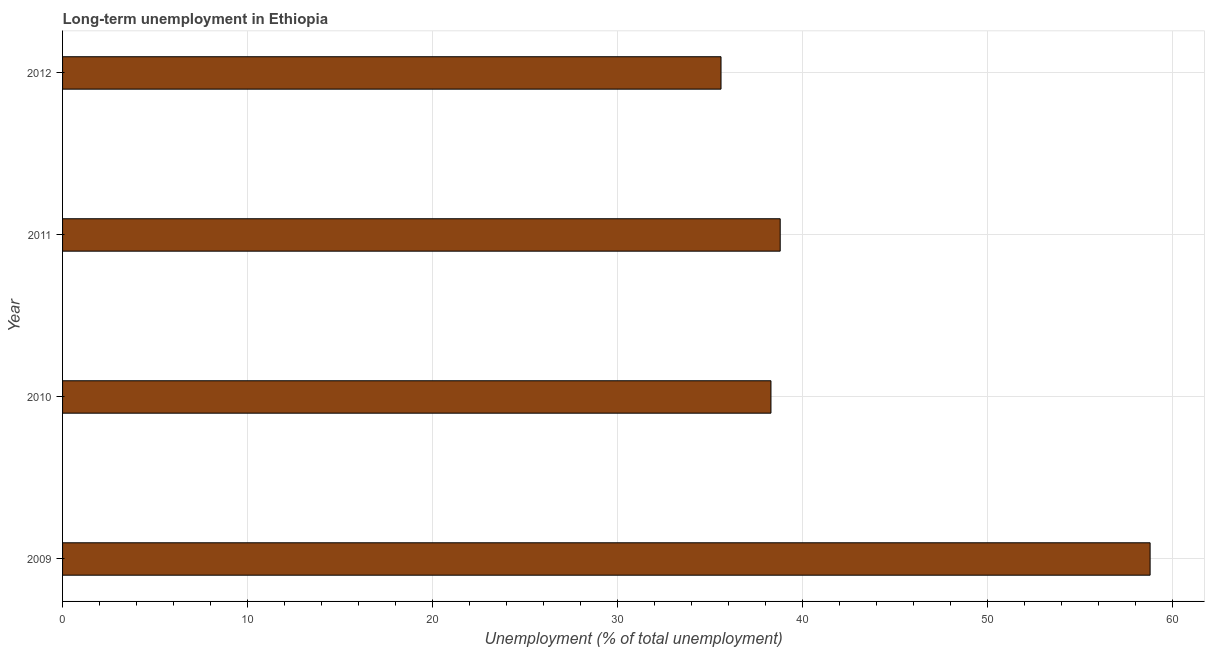Does the graph contain grids?
Your answer should be very brief. Yes. What is the title of the graph?
Provide a succinct answer. Long-term unemployment in Ethiopia. What is the label or title of the X-axis?
Keep it short and to the point. Unemployment (% of total unemployment). What is the label or title of the Y-axis?
Keep it short and to the point. Year. What is the long-term unemployment in 2010?
Offer a terse response. 38.3. Across all years, what is the maximum long-term unemployment?
Make the answer very short. 58.8. Across all years, what is the minimum long-term unemployment?
Give a very brief answer. 35.6. In which year was the long-term unemployment maximum?
Your response must be concise. 2009. In which year was the long-term unemployment minimum?
Provide a short and direct response. 2012. What is the sum of the long-term unemployment?
Make the answer very short. 171.5. What is the difference between the long-term unemployment in 2011 and 2012?
Ensure brevity in your answer.  3.2. What is the average long-term unemployment per year?
Provide a short and direct response. 42.88. What is the median long-term unemployment?
Your response must be concise. 38.55. What is the ratio of the long-term unemployment in 2009 to that in 2011?
Offer a terse response. 1.51. What is the difference between the highest and the lowest long-term unemployment?
Your answer should be compact. 23.2. How many years are there in the graph?
Give a very brief answer. 4. Are the values on the major ticks of X-axis written in scientific E-notation?
Ensure brevity in your answer.  No. What is the Unemployment (% of total unemployment) of 2009?
Ensure brevity in your answer.  58.8. What is the Unemployment (% of total unemployment) of 2010?
Give a very brief answer. 38.3. What is the Unemployment (% of total unemployment) of 2011?
Your answer should be compact. 38.8. What is the Unemployment (% of total unemployment) of 2012?
Offer a very short reply. 35.6. What is the difference between the Unemployment (% of total unemployment) in 2009 and 2010?
Provide a short and direct response. 20.5. What is the difference between the Unemployment (% of total unemployment) in 2009 and 2012?
Your answer should be very brief. 23.2. What is the difference between the Unemployment (% of total unemployment) in 2010 and 2012?
Provide a succinct answer. 2.7. What is the difference between the Unemployment (% of total unemployment) in 2011 and 2012?
Your answer should be very brief. 3.2. What is the ratio of the Unemployment (% of total unemployment) in 2009 to that in 2010?
Offer a terse response. 1.53. What is the ratio of the Unemployment (% of total unemployment) in 2009 to that in 2011?
Give a very brief answer. 1.51. What is the ratio of the Unemployment (% of total unemployment) in 2009 to that in 2012?
Your answer should be very brief. 1.65. What is the ratio of the Unemployment (% of total unemployment) in 2010 to that in 2012?
Your answer should be compact. 1.08. What is the ratio of the Unemployment (% of total unemployment) in 2011 to that in 2012?
Your response must be concise. 1.09. 